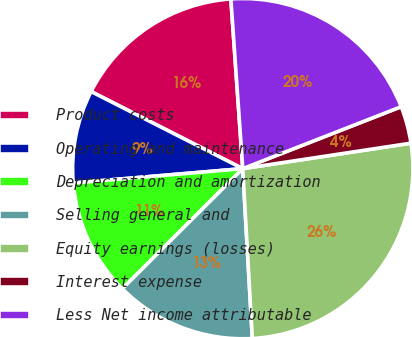Convert chart to OTSL. <chart><loc_0><loc_0><loc_500><loc_500><pie_chart><fcel>Product costs<fcel>Operating and maintenance<fcel>Depreciation and amortization<fcel>Selling general and<fcel>Equity earnings (losses)<fcel>Interest expense<fcel>Less Net income attributable<nl><fcel>16.4%<fcel>8.83%<fcel>11.13%<fcel>13.42%<fcel>26.49%<fcel>3.54%<fcel>20.18%<nl></chart> 